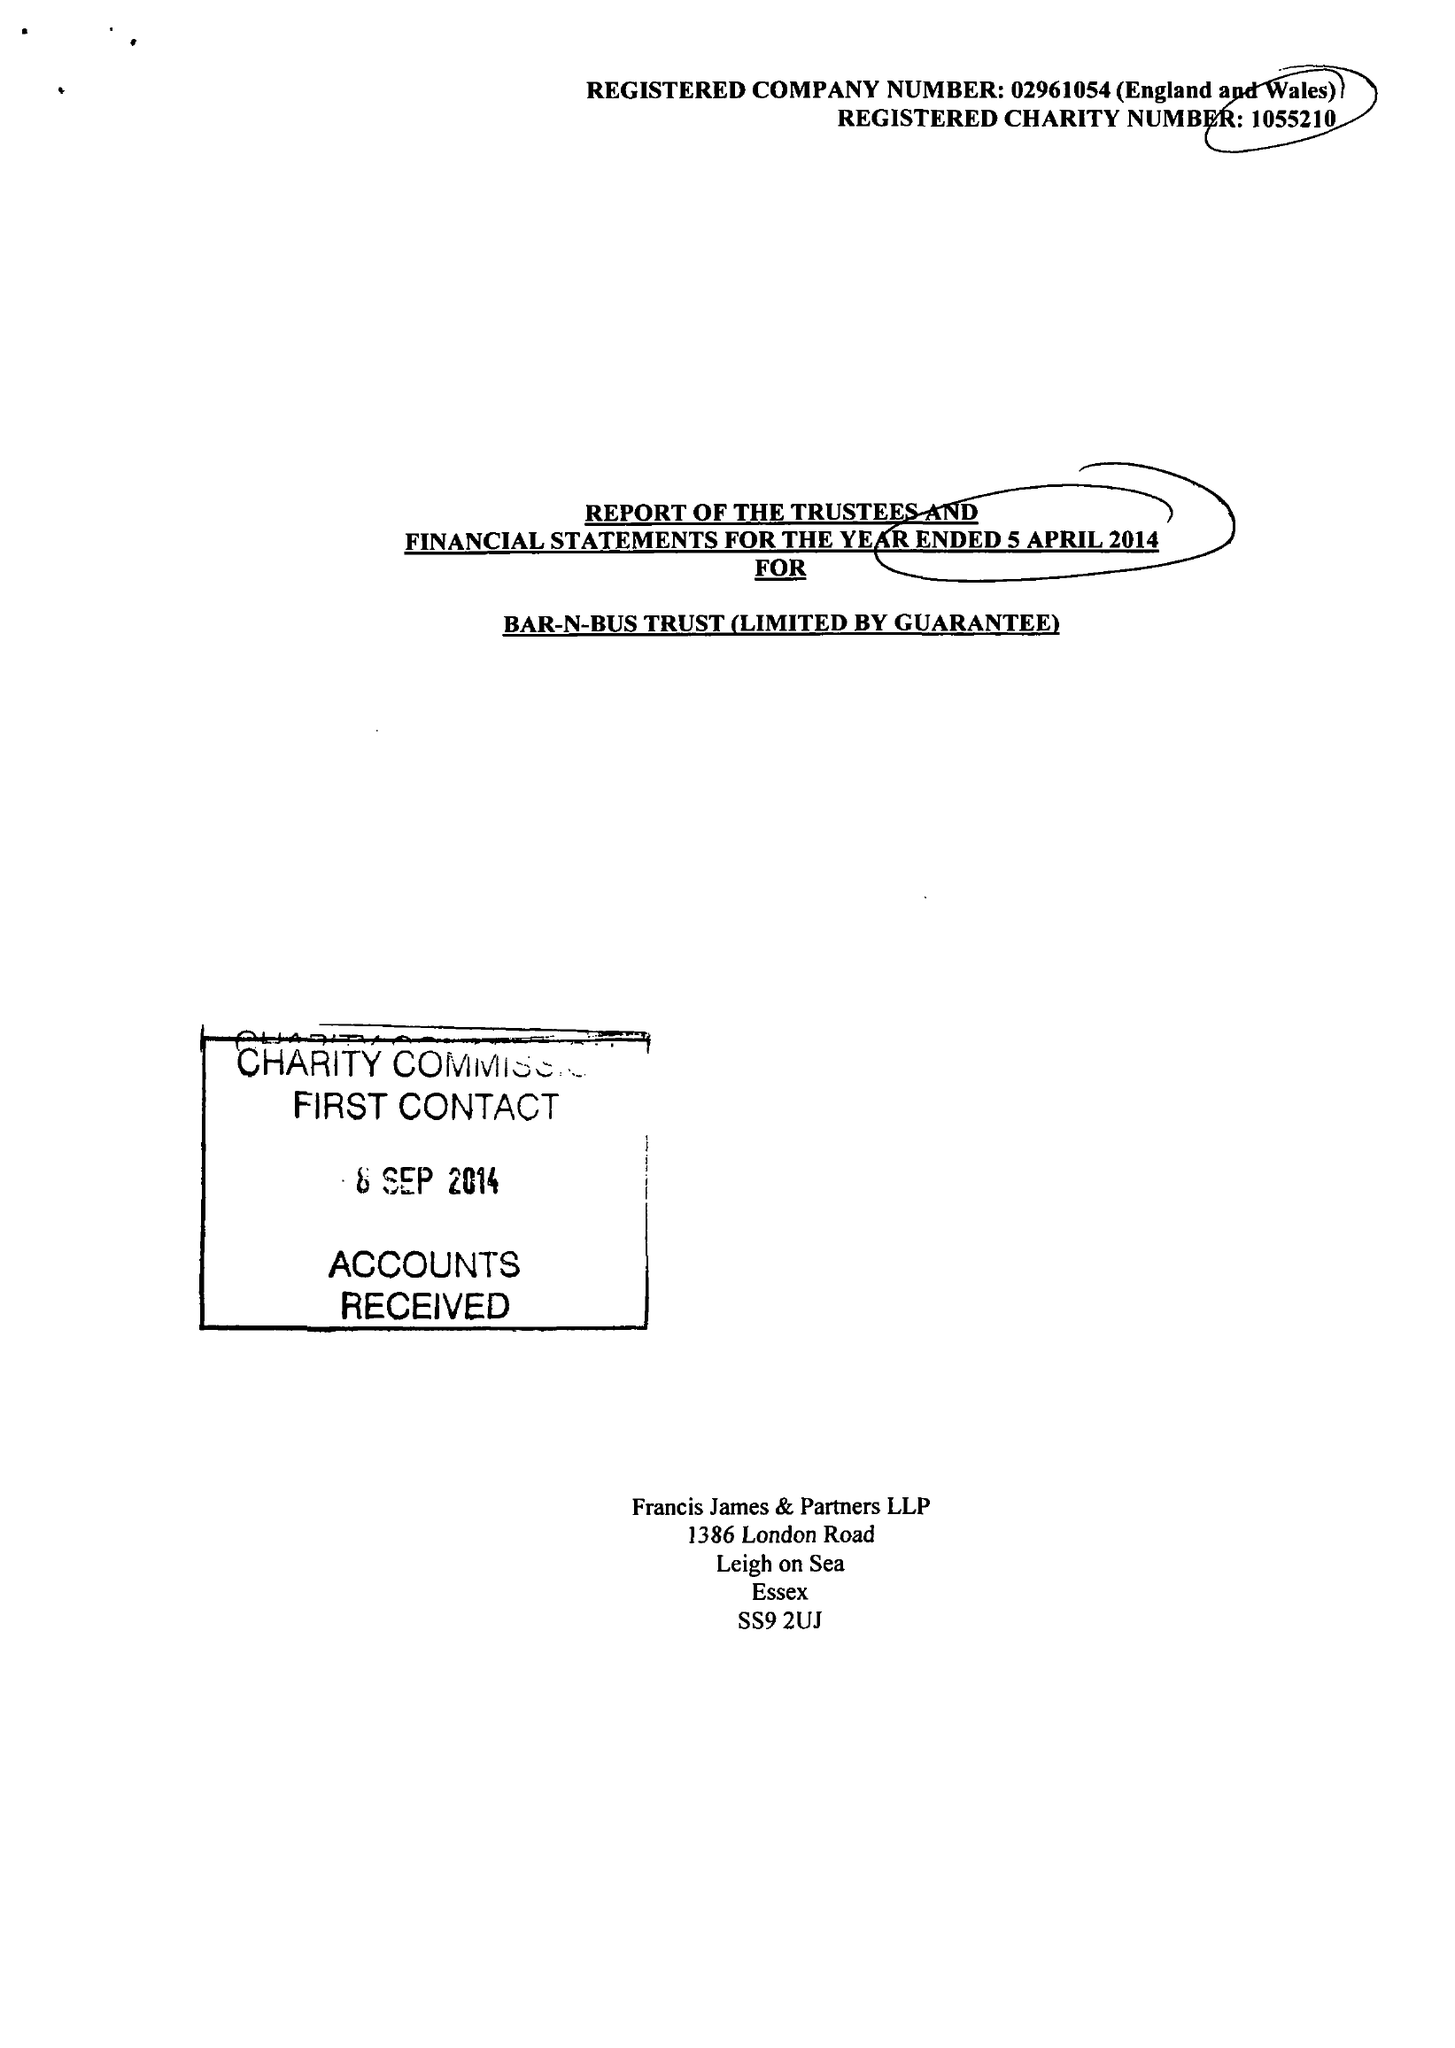What is the value for the address__street_line?
Answer the question using a single word or phrase. 1386 LONDON ROAD 